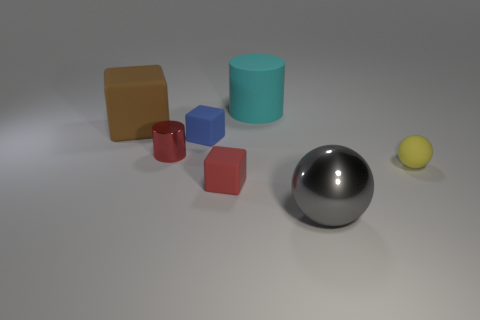What time of day does the lighting in this image suggest? The image doesn't provide a direct indication of an outdoor environment, but the soft shadows and neutral backdrop suggest an interior setting with artificial lighting, resembling studio lighting commonly used in photography, which doesn't correlate with a specific time of day. 